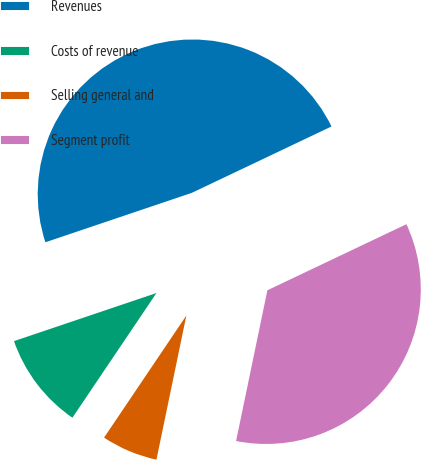Convert chart to OTSL. <chart><loc_0><loc_0><loc_500><loc_500><pie_chart><fcel>Revenues<fcel>Costs of revenue<fcel>Selling general and<fcel>Segment profit<nl><fcel>48.12%<fcel>10.38%<fcel>6.18%<fcel>35.32%<nl></chart> 